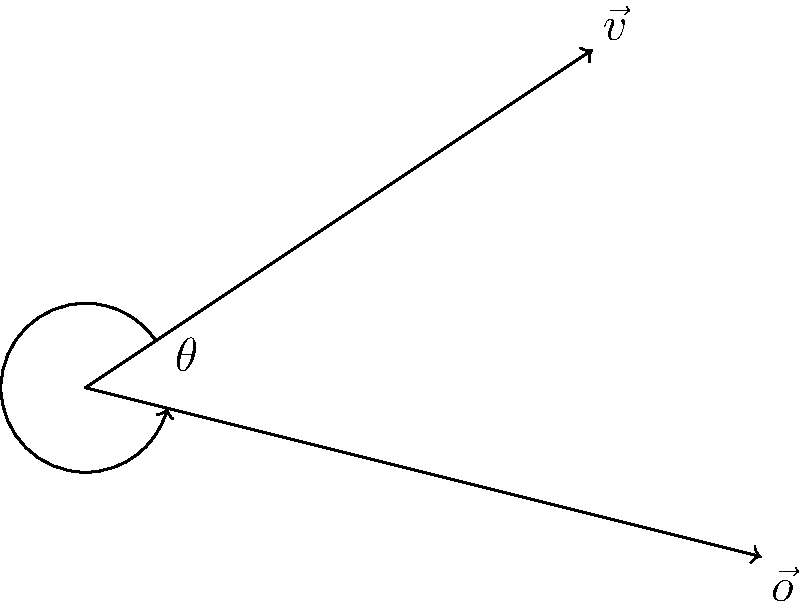In a 2D game, a character is moving with velocity vector $\vec{v} = (3, 2)$ and encounters an obstacle with normal vector $\vec{o} = (4, -1)$. Calculate the angle $\theta$ between the character's movement direction and the obstacle's normal vector using the dot product. Round your answer to the nearest degree. To find the angle between two vectors using the dot product, we follow these steps:

1) The dot product formula for two vectors $\vec{a}$ and $\vec{b}$ is:
   $$\vec{a} \cdot \vec{b} = |\vec{a}||\vec{b}|\cos\theta$$

2) We can rearrange this to solve for $\theta$:
   $$\theta = \arccos\left(\frac{\vec{a} \cdot \vec{b}}{|\vec{a}||\vec{b}|}\right)$$

3) Calculate the dot product $\vec{v} \cdot \vec{o}$:
   $$\vec{v} \cdot \vec{o} = (3)(4) + (2)(-1) = 12 - 2 = 10$$

4) Calculate the magnitudes:
   $$|\vec{v}| = \sqrt{3^2 + 2^2} = \sqrt{13}$$
   $$|\vec{o}| = \sqrt{4^2 + (-1)^2} = \sqrt{17}$$

5) Substitute into the angle formula:
   $$\theta = \arccos\left(\frac{10}{\sqrt{13}\sqrt{17}}\right)$$

6) Evaluate and convert to degrees:
   $$\theta \approx 0.5611 \text{ radians} \approx 32.14°$$

7) Rounding to the nearest degree:
   $$\theta \approx 32°$$
Answer: 32° 